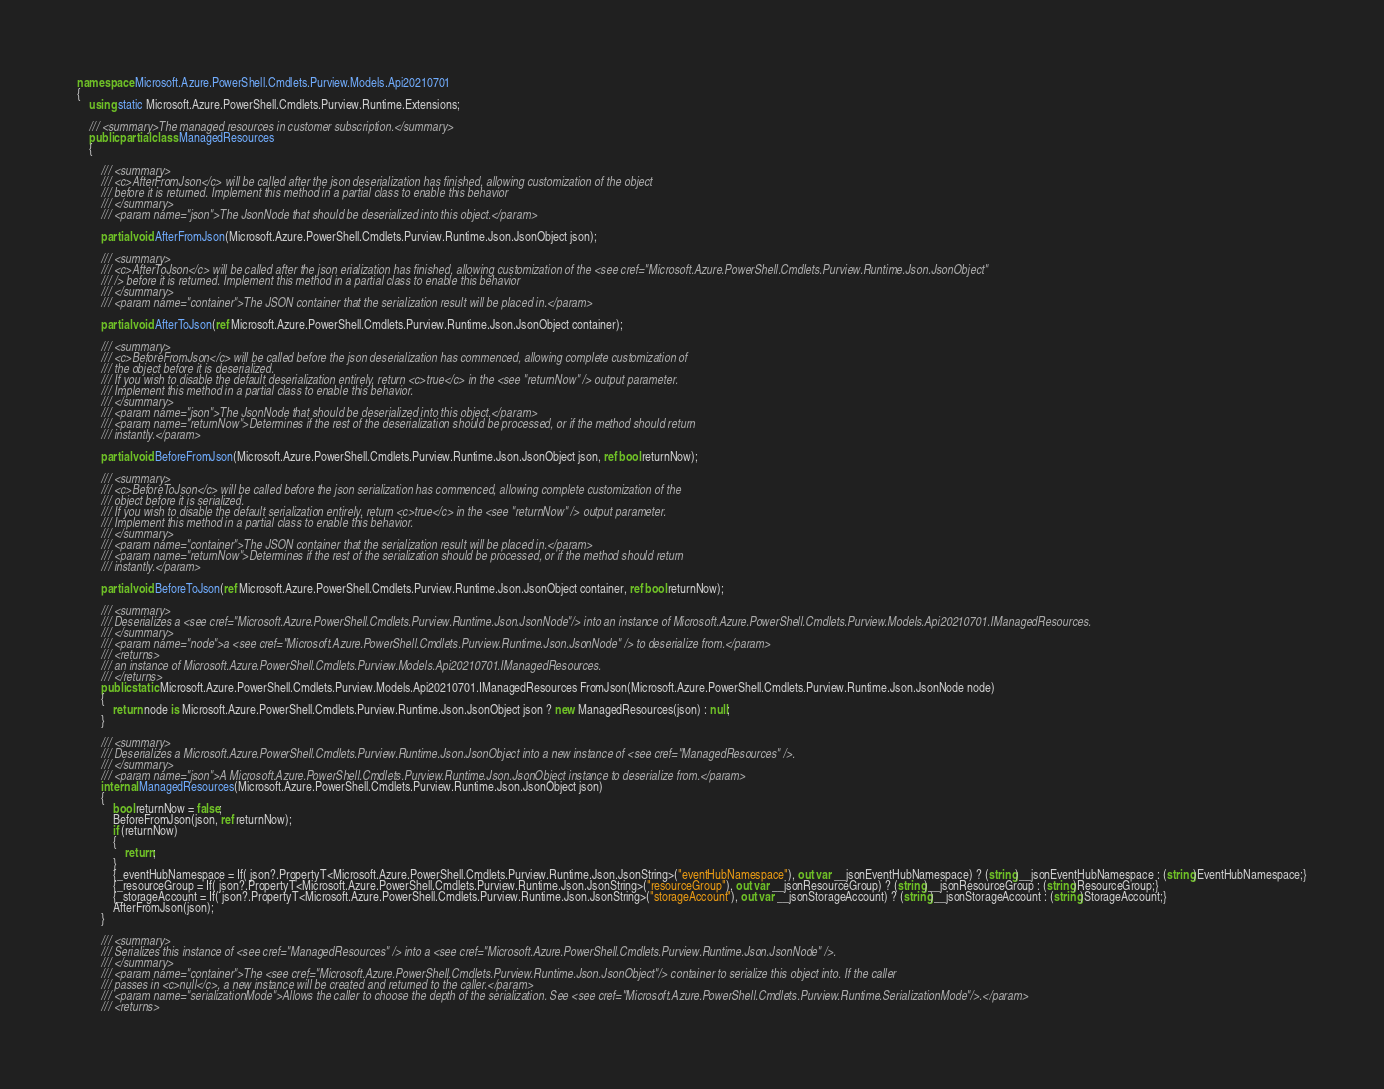Convert code to text. <code><loc_0><loc_0><loc_500><loc_500><_C#_>namespace Microsoft.Azure.PowerShell.Cmdlets.Purview.Models.Api20210701
{
    using static Microsoft.Azure.PowerShell.Cmdlets.Purview.Runtime.Extensions;

    /// <summary>The managed resources in customer subscription.</summary>
    public partial class ManagedResources
    {

        /// <summary>
        /// <c>AfterFromJson</c> will be called after the json deserialization has finished, allowing customization of the object
        /// before it is returned. Implement this method in a partial class to enable this behavior
        /// </summary>
        /// <param name="json">The JsonNode that should be deserialized into this object.</param>

        partial void AfterFromJson(Microsoft.Azure.PowerShell.Cmdlets.Purview.Runtime.Json.JsonObject json);

        /// <summary>
        /// <c>AfterToJson</c> will be called after the json erialization has finished, allowing customization of the <see cref="Microsoft.Azure.PowerShell.Cmdlets.Purview.Runtime.Json.JsonObject"
        /// /> before it is returned. Implement this method in a partial class to enable this behavior
        /// </summary>
        /// <param name="container">The JSON container that the serialization result will be placed in.</param>

        partial void AfterToJson(ref Microsoft.Azure.PowerShell.Cmdlets.Purview.Runtime.Json.JsonObject container);

        /// <summary>
        /// <c>BeforeFromJson</c> will be called before the json deserialization has commenced, allowing complete customization of
        /// the object before it is deserialized.
        /// If you wish to disable the default deserialization entirely, return <c>true</c> in the <see "returnNow" /> output parameter.
        /// Implement this method in a partial class to enable this behavior.
        /// </summary>
        /// <param name="json">The JsonNode that should be deserialized into this object.</param>
        /// <param name="returnNow">Determines if the rest of the deserialization should be processed, or if the method should return
        /// instantly.</param>

        partial void BeforeFromJson(Microsoft.Azure.PowerShell.Cmdlets.Purview.Runtime.Json.JsonObject json, ref bool returnNow);

        /// <summary>
        /// <c>BeforeToJson</c> will be called before the json serialization has commenced, allowing complete customization of the
        /// object before it is serialized.
        /// If you wish to disable the default serialization entirely, return <c>true</c> in the <see "returnNow" /> output parameter.
        /// Implement this method in a partial class to enable this behavior.
        /// </summary>
        /// <param name="container">The JSON container that the serialization result will be placed in.</param>
        /// <param name="returnNow">Determines if the rest of the serialization should be processed, or if the method should return
        /// instantly.</param>

        partial void BeforeToJson(ref Microsoft.Azure.PowerShell.Cmdlets.Purview.Runtime.Json.JsonObject container, ref bool returnNow);

        /// <summary>
        /// Deserializes a <see cref="Microsoft.Azure.PowerShell.Cmdlets.Purview.Runtime.Json.JsonNode"/> into an instance of Microsoft.Azure.PowerShell.Cmdlets.Purview.Models.Api20210701.IManagedResources.
        /// </summary>
        /// <param name="node">a <see cref="Microsoft.Azure.PowerShell.Cmdlets.Purview.Runtime.Json.JsonNode" /> to deserialize from.</param>
        /// <returns>
        /// an instance of Microsoft.Azure.PowerShell.Cmdlets.Purview.Models.Api20210701.IManagedResources.
        /// </returns>
        public static Microsoft.Azure.PowerShell.Cmdlets.Purview.Models.Api20210701.IManagedResources FromJson(Microsoft.Azure.PowerShell.Cmdlets.Purview.Runtime.Json.JsonNode node)
        {
            return node is Microsoft.Azure.PowerShell.Cmdlets.Purview.Runtime.Json.JsonObject json ? new ManagedResources(json) : null;
        }

        /// <summary>
        /// Deserializes a Microsoft.Azure.PowerShell.Cmdlets.Purview.Runtime.Json.JsonObject into a new instance of <see cref="ManagedResources" />.
        /// </summary>
        /// <param name="json">A Microsoft.Azure.PowerShell.Cmdlets.Purview.Runtime.Json.JsonObject instance to deserialize from.</param>
        internal ManagedResources(Microsoft.Azure.PowerShell.Cmdlets.Purview.Runtime.Json.JsonObject json)
        {
            bool returnNow = false;
            BeforeFromJson(json, ref returnNow);
            if (returnNow)
            {
                return;
            }
            {_eventHubNamespace = If( json?.PropertyT<Microsoft.Azure.PowerShell.Cmdlets.Purview.Runtime.Json.JsonString>("eventHubNamespace"), out var __jsonEventHubNamespace) ? (string)__jsonEventHubNamespace : (string)EventHubNamespace;}
            {_resourceGroup = If( json?.PropertyT<Microsoft.Azure.PowerShell.Cmdlets.Purview.Runtime.Json.JsonString>("resourceGroup"), out var __jsonResourceGroup) ? (string)__jsonResourceGroup : (string)ResourceGroup;}
            {_storageAccount = If( json?.PropertyT<Microsoft.Azure.PowerShell.Cmdlets.Purview.Runtime.Json.JsonString>("storageAccount"), out var __jsonStorageAccount) ? (string)__jsonStorageAccount : (string)StorageAccount;}
            AfterFromJson(json);
        }

        /// <summary>
        /// Serializes this instance of <see cref="ManagedResources" /> into a <see cref="Microsoft.Azure.PowerShell.Cmdlets.Purview.Runtime.Json.JsonNode" />.
        /// </summary>
        /// <param name="container">The <see cref="Microsoft.Azure.PowerShell.Cmdlets.Purview.Runtime.Json.JsonObject"/> container to serialize this object into. If the caller
        /// passes in <c>null</c>, a new instance will be created and returned to the caller.</param>
        /// <param name="serializationMode">Allows the caller to choose the depth of the serialization. See <see cref="Microsoft.Azure.PowerShell.Cmdlets.Purview.Runtime.SerializationMode"/>.</param>
        /// <returns></code> 